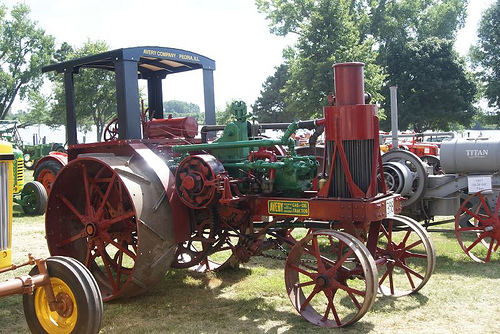<image>
Can you confirm if the tree is behind the tractor? Yes. From this viewpoint, the tree is positioned behind the tractor, with the tractor partially or fully occluding the tree. 